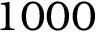<formula> <loc_0><loc_0><loc_500><loc_500>1 0 0 0</formula> 